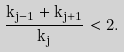Convert formula to latex. <formula><loc_0><loc_0><loc_500><loc_500>\label l { g t } \frac { k _ { j - 1 } + k _ { j + 1 } } { k _ { j } } < 2 .</formula> 